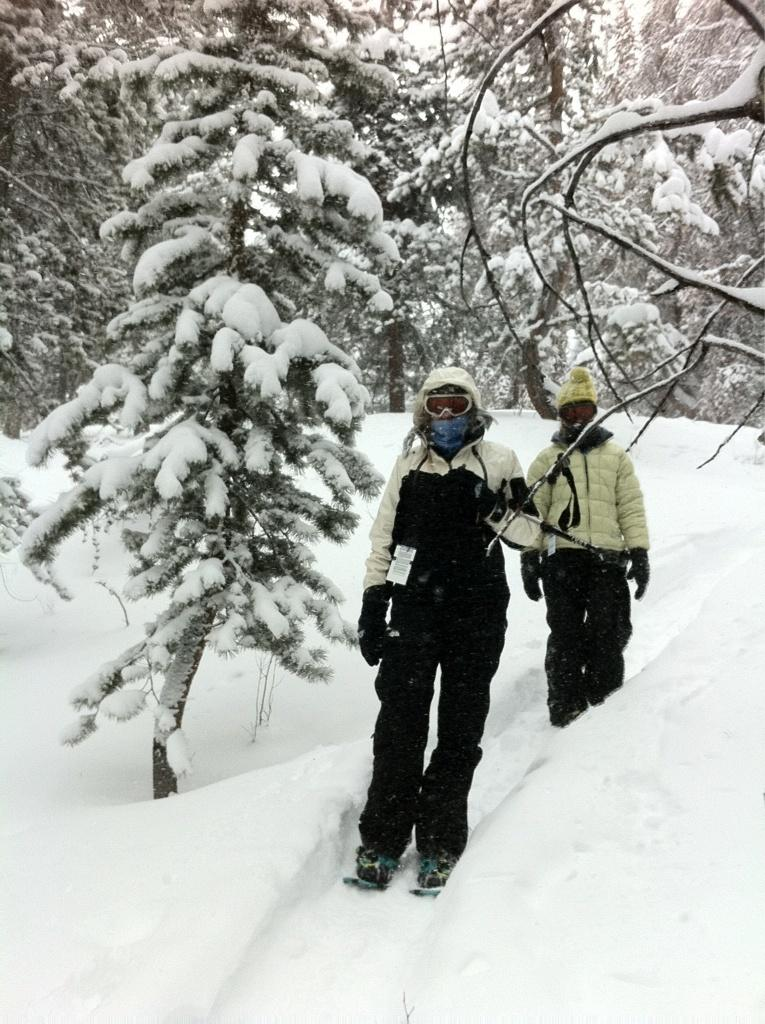How many people are in the image? There are two people in the foreground of the image. What are the people wearing? The people are wearing jackets and masks. What activity are the people engaged in? The people are skating on the snow. What can be seen in the background of the image? There are trees in the background of the image. What type of spoon can be seen in the image? There is no spoon present in the image. Can you tell me how many pairs of scissors are visible in the image? There are no scissors present in the image. 